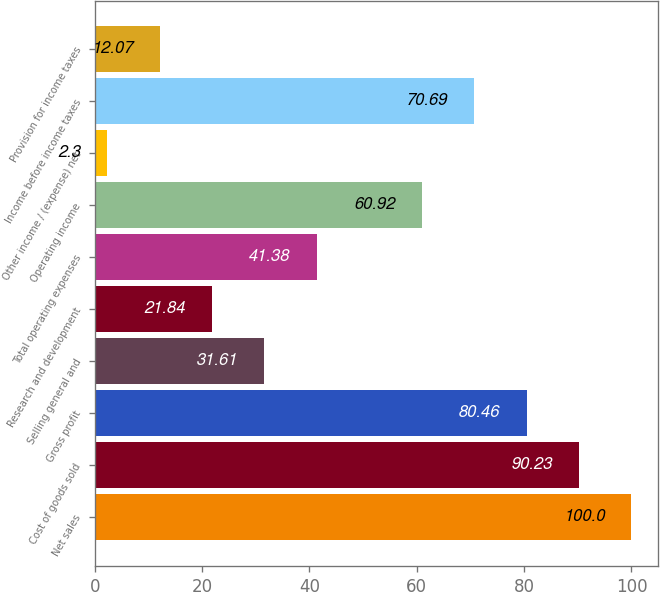<chart> <loc_0><loc_0><loc_500><loc_500><bar_chart><fcel>Net sales<fcel>Cost of goods sold<fcel>Gross profit<fcel>Selling general and<fcel>Research and development<fcel>Total operating expenses<fcel>Operating income<fcel>Other income / (expense) net<fcel>Income before income taxes<fcel>Provision for income taxes<nl><fcel>100<fcel>90.23<fcel>80.46<fcel>31.61<fcel>21.84<fcel>41.38<fcel>60.92<fcel>2.3<fcel>70.69<fcel>12.07<nl></chart> 